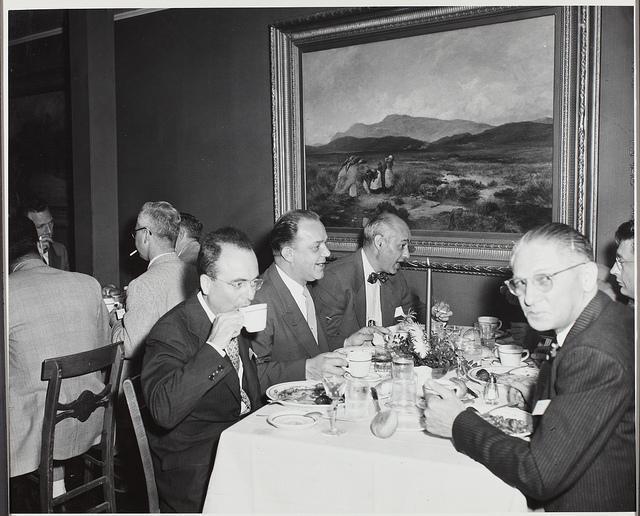How many are sipping?
Give a very brief answer. 1. How many people can be seen?
Give a very brief answer. 6. 